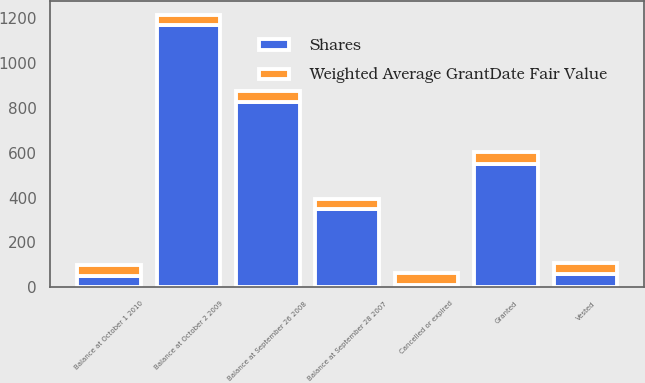Convert chart. <chart><loc_0><loc_0><loc_500><loc_500><stacked_bar_chart><ecel><fcel>Balance at September 28 2007<fcel>Granted<fcel>Vested<fcel>Cancelled or expired<fcel>Balance at September 26 2008<fcel>Balance at October 2 2009<fcel>Balance at October 1 2010<nl><fcel>Shares<fcel>348<fcel>552<fcel>61<fcel>11<fcel>828<fcel>1172<fcel>52.36<nl><fcel>Weighted Average GrantDate Fair Value<fcel>44.38<fcel>52.58<fcel>46.04<fcel>52.36<fcel>49.62<fcel>42.89<fcel>46.91<nl></chart> 